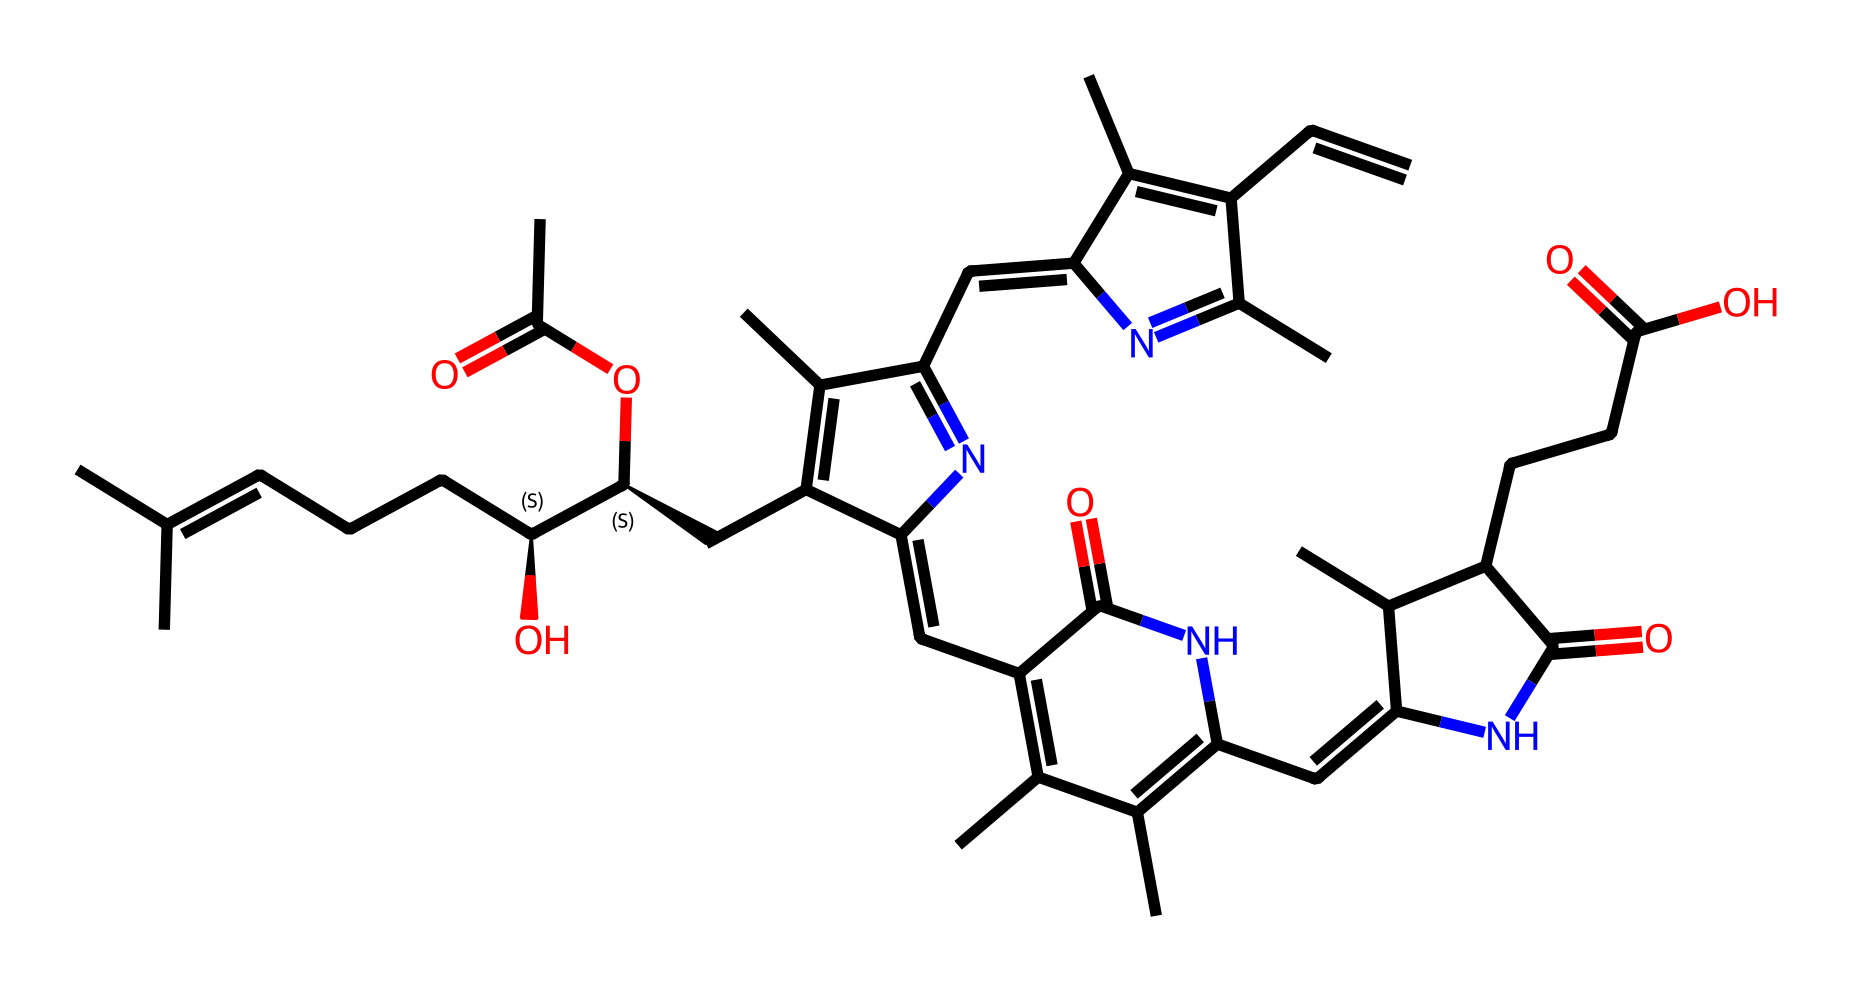What is the total number of carbon atoms in this compound? By inspecting the structure represented by the SMILES, I can count the number of occurrences of 'C', which indicates carbon atoms. In this case, there are 30 carbons in the structure.
Answer: 30 How many nitrogen atoms are present in this chemical? The count of nitrogen atoms can be done by searching for the 'N' symbols in the SMILES formula. After reviewing the structure, I can identify there are 6 nitrogen atoms.
Answer: 6 Which parts of the chemical are likely to interact with light during photosynthesis? The presence of double bonds (C=C) in the structure suggests areas that can absorb light. Specifically, the polyene chain part of chlorophyll, where there are alternating double bonds, is crucial for light absorption.
Answer: polyene chain What functional groups are present in this chlorophyll structure? Analyzing the SMILES structure, I can identify functional groups such as amide (due to the 'C(=O)N' formations) and carboxylic acid (indicated by 'C(=O)O'). These contribute to the solubility and reactivity in biological systems.
Answer: amide and carboxylic acid How does this chlorophyll structure differ from typical coordination compounds? In coordination compounds, specific central metal ions coordinate with surrounding ligands. While chlorophyll does interact with metals such as magnesium, its complex organic structure with a long carbon chain is not typical of simpler coordination compounds.
Answer: organic structure with coordination aspect 